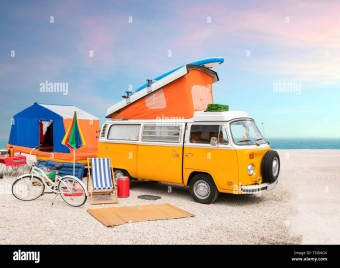How many chairs would there be in the image now that no more chair has been moved to the scene? There is one chair visible in the image, located to the left side near the camper van, complementing the casual, outdoor setting. 